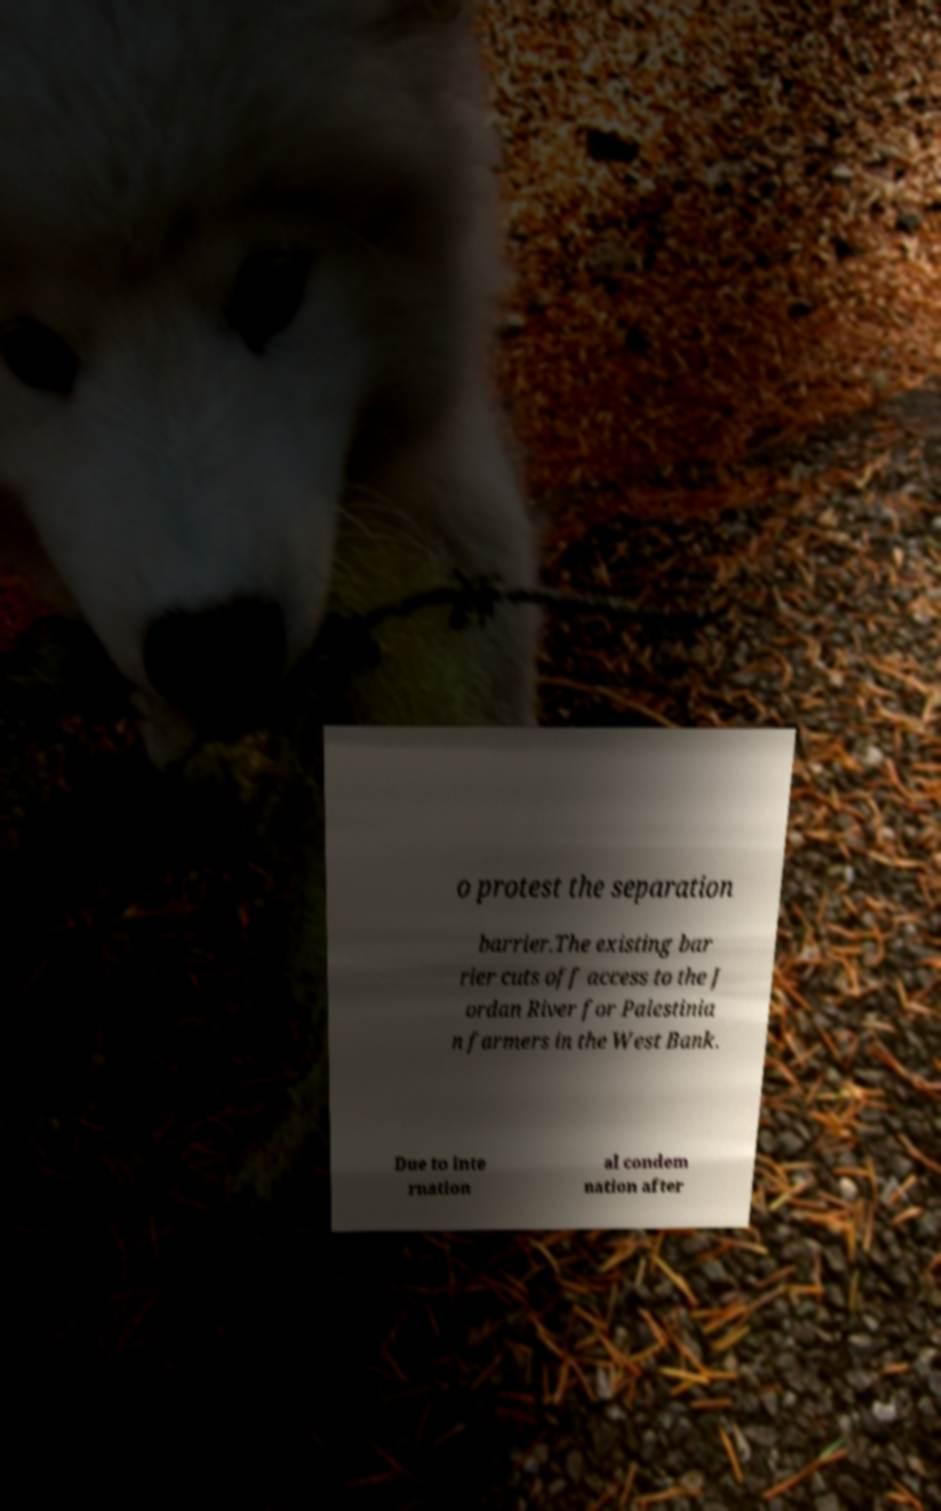I need the written content from this picture converted into text. Can you do that? o protest the separation barrier.The existing bar rier cuts off access to the J ordan River for Palestinia n farmers in the West Bank. Due to inte rnation al condem nation after 